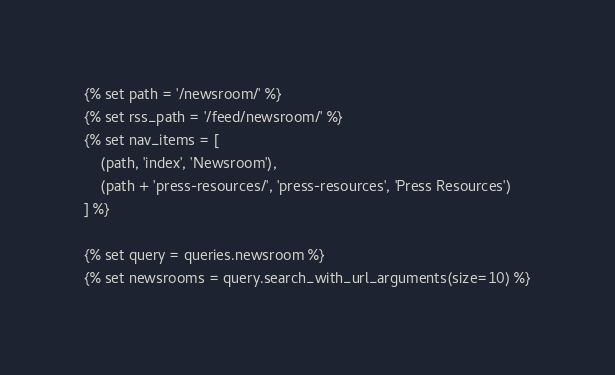<code> <loc_0><loc_0><loc_500><loc_500><_HTML_>
{% set path = '/newsroom/' %}
{% set rss_path = '/feed/newsroom/' %}
{% set nav_items = [
    (path, 'index', 'Newsroom'),
    (path + 'press-resources/', 'press-resources', 'Press Resources')
] %}

{% set query = queries.newsroom %}
{% set newsrooms = query.search_with_url_arguments(size=10) %}
</code> 